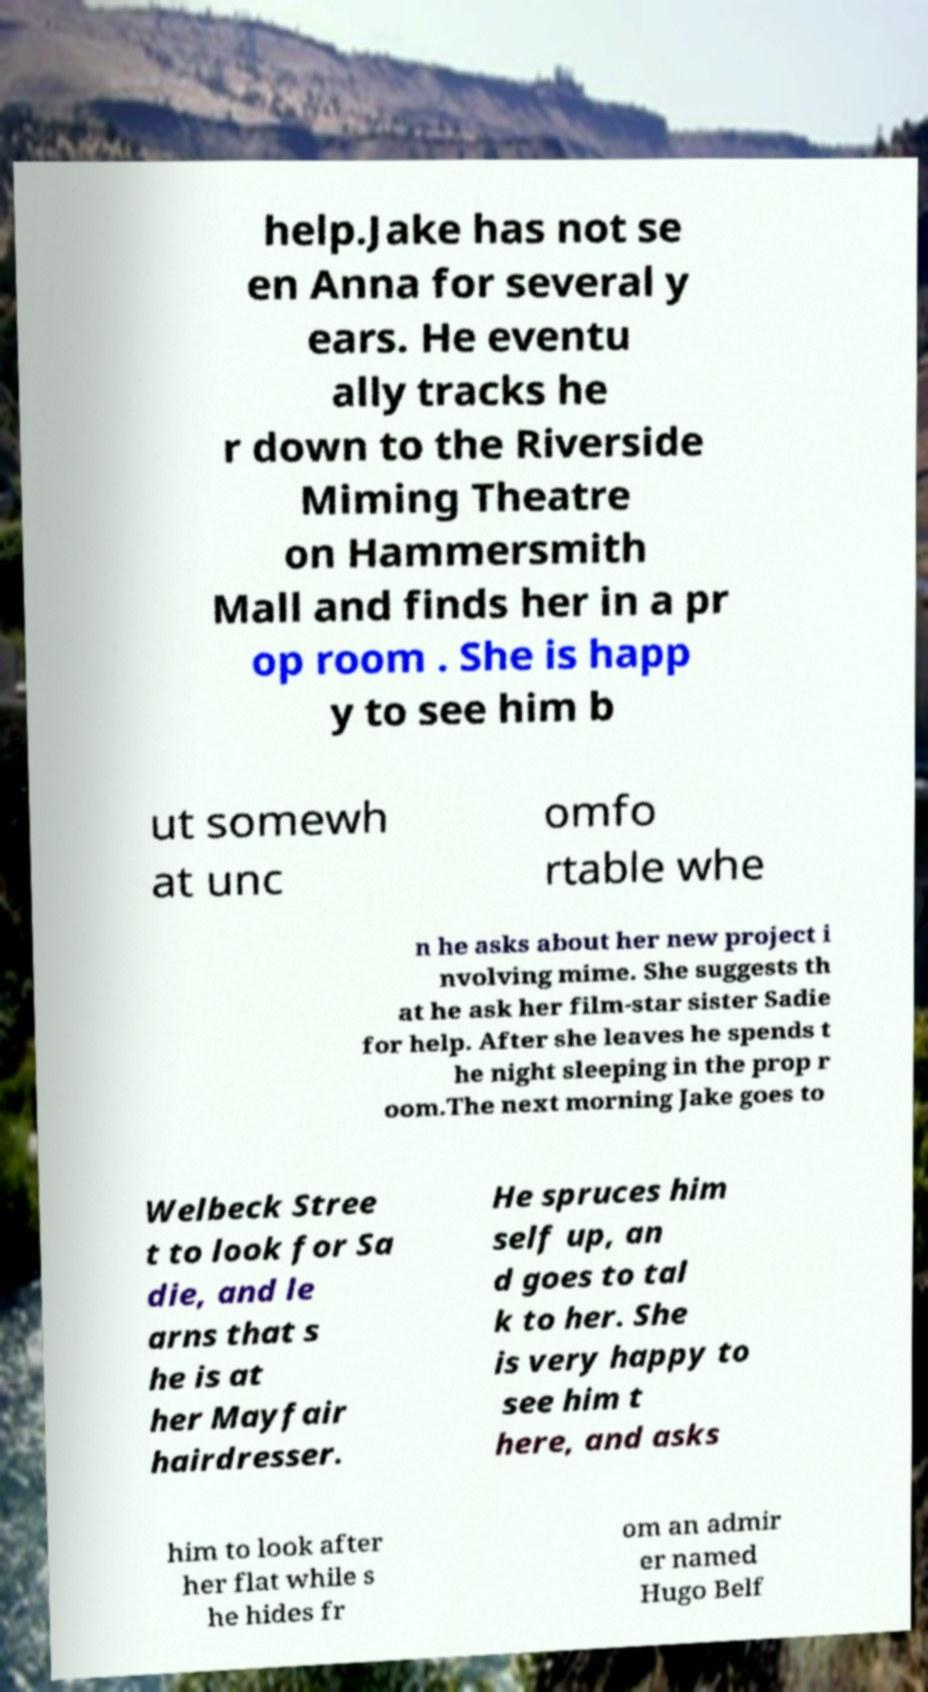Please identify and transcribe the text found in this image. help.Jake has not se en Anna for several y ears. He eventu ally tracks he r down to the Riverside Miming Theatre on Hammersmith Mall and finds her in a pr op room . She is happ y to see him b ut somewh at unc omfo rtable whe n he asks about her new project i nvolving mime. She suggests th at he ask her film-star sister Sadie for help. After she leaves he spends t he night sleeping in the prop r oom.The next morning Jake goes to Welbeck Stree t to look for Sa die, and le arns that s he is at her Mayfair hairdresser. He spruces him self up, an d goes to tal k to her. She is very happy to see him t here, and asks him to look after her flat while s he hides fr om an admir er named Hugo Belf 